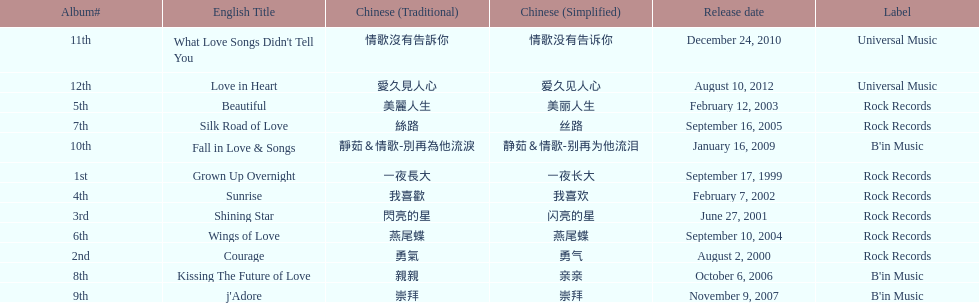Which album was released later, beautiful, or j'adore? J'adore. 